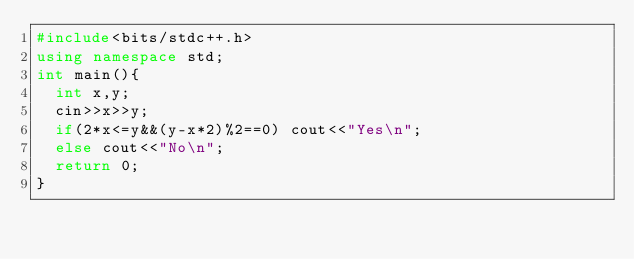<code> <loc_0><loc_0><loc_500><loc_500><_C++_>#include<bits/stdc++.h>
using namespace std;
int main(){
	int x,y;
	cin>>x>>y;
	if(2*x<=y&&(y-x*2)%2==0) cout<<"Yes\n";
	else cout<<"No\n";
	return 0;
}</code> 